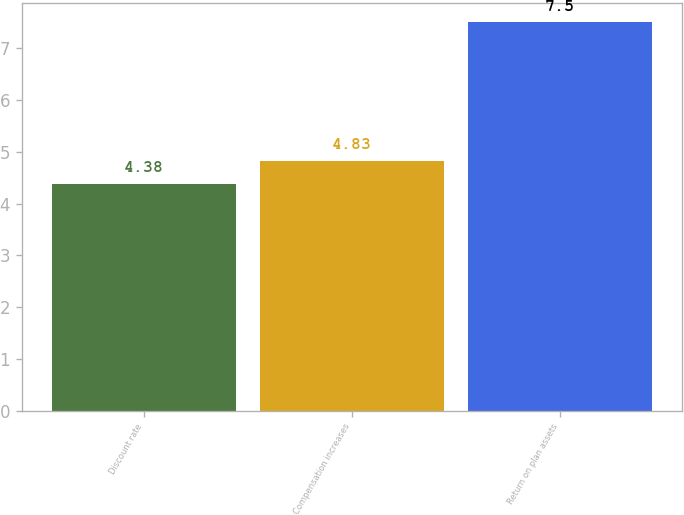Convert chart. <chart><loc_0><loc_0><loc_500><loc_500><bar_chart><fcel>Discount rate<fcel>Compensation increases<fcel>Return on plan assets<nl><fcel>4.38<fcel>4.83<fcel>7.5<nl></chart> 